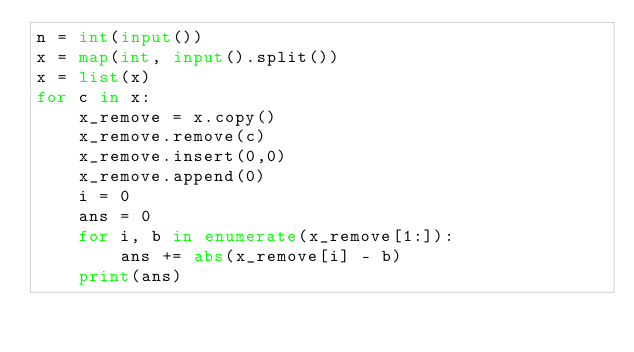Convert code to text. <code><loc_0><loc_0><loc_500><loc_500><_Python_>n = int(input())
x = map(int, input().split())
x = list(x)
for c in x:
    x_remove = x.copy()
    x_remove.remove(c)
    x_remove.insert(0,0)
    x_remove.append(0)
    i = 0
    ans = 0
    for i, b in enumerate(x_remove[1:]):
        ans += abs(x_remove[i] - b)        
    print(ans)</code> 